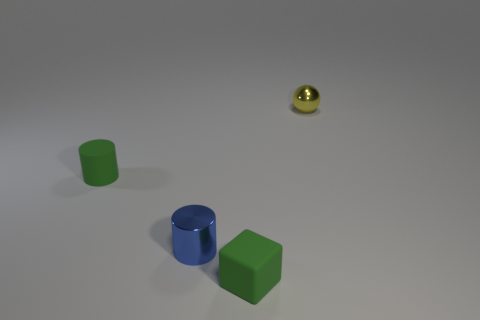Add 2 small metal cylinders. How many objects exist? 6 Subtract all cubes. How many objects are left? 3 Add 4 small red objects. How many small red objects exist? 4 Subtract 0 red spheres. How many objects are left? 4 Subtract all tiny blue metallic cylinders. Subtract all tiny gray matte balls. How many objects are left? 3 Add 4 cubes. How many cubes are left? 5 